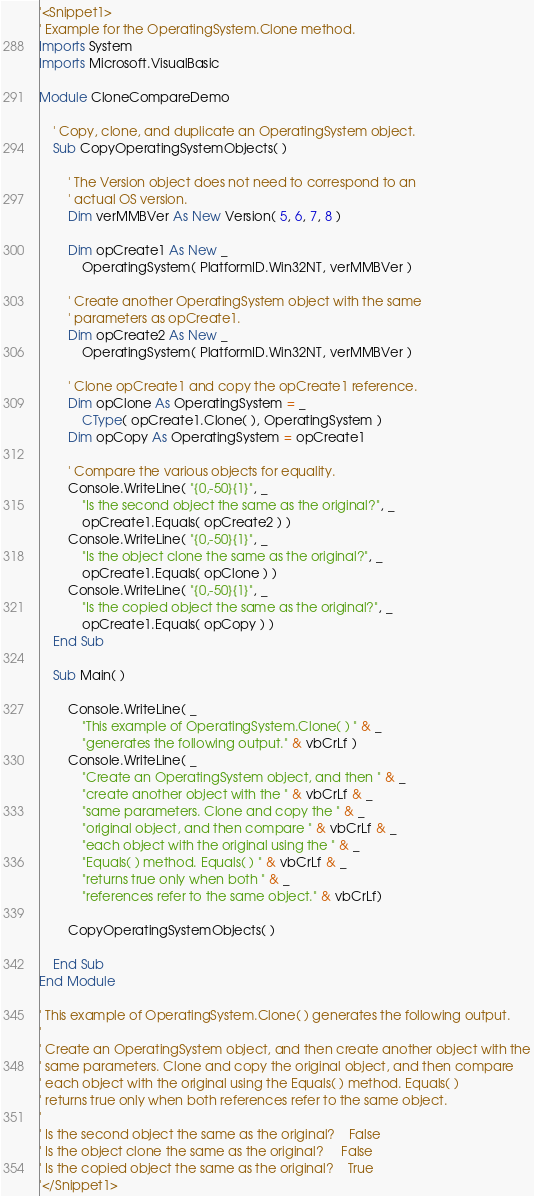Convert code to text. <code><loc_0><loc_0><loc_500><loc_500><_VisualBasic_>'<Snippet1>
' Example for the OperatingSystem.Clone method.
Imports System
Imports Microsoft.VisualBasic

Module CloneCompareDemo
    
    ' Copy, clone, and duplicate an OperatingSystem object.
    Sub CopyOperatingSystemObjects( )

        ' The Version object does not need to correspond to an 
        ' actual OS version.
        Dim verMMBVer As New Version( 5, 6, 7, 8 )
            
        Dim opCreate1 As New _
            OperatingSystem( PlatformID.Win32NT, verMMBVer )
            
        ' Create another OperatingSystem object with the same 
        ' parameters as opCreate1.
        Dim opCreate2 As New _
            OperatingSystem( PlatformID.Win32NT, verMMBVer )
            
        ' Clone opCreate1 and copy the opCreate1 reference.
        Dim opClone As OperatingSystem = _
            CType( opCreate1.Clone( ), OperatingSystem )
        Dim opCopy As OperatingSystem = opCreate1

        ' Compare the various objects for equality.
        Console.WriteLine( "{0,-50}{1}", _
            "Is the second object the same as the original?", _
            opCreate1.Equals( opCreate2 ) )
        Console.WriteLine( "{0,-50}{1}", _
            "Is the object clone the same as the original?", _
            opCreate1.Equals( opClone ) )
        Console.WriteLine( "{0,-50}{1}", _
            "Is the copied object the same as the original?", _
            opCreate1.Equals( opCopy ) )
    End Sub 
        
    Sub Main( )

        Console.WriteLine( _
            "This example of OperatingSystem.Clone( ) " & _
            "generates the following output." & vbCrLf )
        Console.WriteLine( _
            "Create an OperatingSystem object, and then " & _
            "create another object with the " & vbCrLf & _
            "same parameters. Clone and copy the " & _
            "original object, and then compare " & vbCrLf & _
            "each object with the original using the " & _
            "Equals( ) method. Equals( ) " & vbCrLf & _
            "returns true only when both " & _
            "references refer to the same object." & vbCrLf)
            
        CopyOperatingSystemObjects( )

    End Sub 
End Module 

' This example of OperatingSystem.Clone( ) generates the following output.
' 
' Create an OperatingSystem object, and then create another object with the
' same parameters. Clone and copy the original object, and then compare
' each object with the original using the Equals( ) method. Equals( )
' returns true only when both references refer to the same object.
' 
' Is the second object the same as the original?    False
' Is the object clone the same as the original?     False
' Is the copied object the same as the original?    True
'</Snippet1>
</code> 